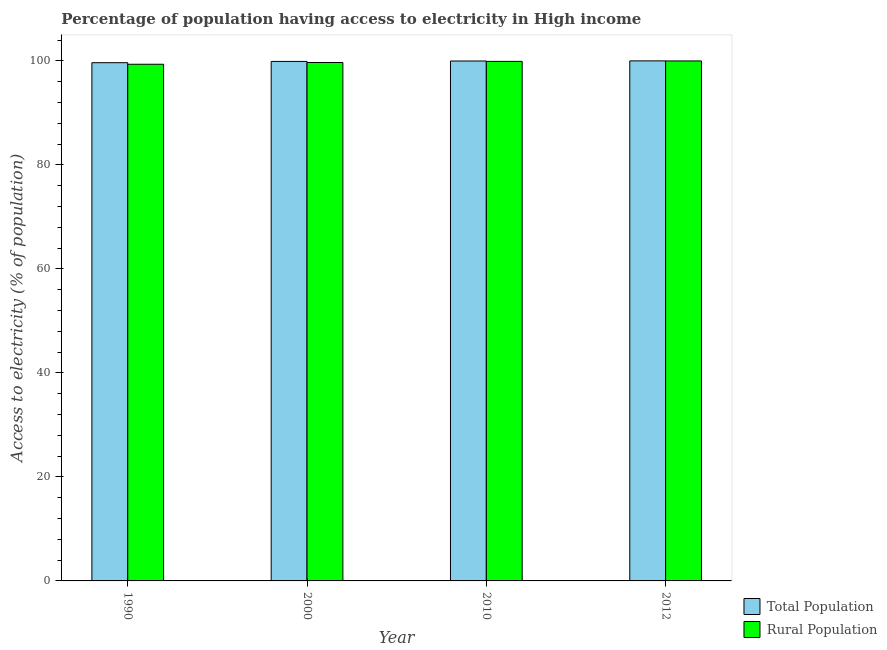How many different coloured bars are there?
Your answer should be compact. 2. How many groups of bars are there?
Your answer should be very brief. 4. Are the number of bars on each tick of the X-axis equal?
Ensure brevity in your answer.  Yes. How many bars are there on the 2nd tick from the left?
Keep it short and to the point. 2. How many bars are there on the 2nd tick from the right?
Keep it short and to the point. 2. What is the label of the 4th group of bars from the left?
Give a very brief answer. 2012. What is the percentage of population having access to electricity in 2010?
Offer a very short reply. 99.97. Across all years, what is the maximum percentage of population having access to electricity?
Provide a short and direct response. 99.99. Across all years, what is the minimum percentage of population having access to electricity?
Offer a very short reply. 99.64. What is the total percentage of rural population having access to electricity in the graph?
Provide a short and direct response. 398.9. What is the difference between the percentage of population having access to electricity in 1990 and that in 2010?
Keep it short and to the point. -0.33. What is the difference between the percentage of rural population having access to electricity in 1990 and the percentage of population having access to electricity in 2010?
Ensure brevity in your answer.  -0.55. What is the average percentage of rural population having access to electricity per year?
Make the answer very short. 99.73. In how many years, is the percentage of population having access to electricity greater than 88 %?
Provide a succinct answer. 4. What is the ratio of the percentage of rural population having access to electricity in 1990 to that in 2000?
Keep it short and to the point. 1. What is the difference between the highest and the second highest percentage of rural population having access to electricity?
Give a very brief answer. 0.08. What is the difference between the highest and the lowest percentage of rural population having access to electricity?
Your answer should be compact. 0.64. Is the sum of the percentage of rural population having access to electricity in 1990 and 2012 greater than the maximum percentage of population having access to electricity across all years?
Provide a short and direct response. Yes. What does the 1st bar from the left in 1990 represents?
Offer a very short reply. Total Population. What does the 2nd bar from the right in 2010 represents?
Offer a very short reply. Total Population. How many bars are there?
Provide a succinct answer. 8. How many years are there in the graph?
Ensure brevity in your answer.  4. Are the values on the major ticks of Y-axis written in scientific E-notation?
Provide a short and direct response. No. Does the graph contain grids?
Your response must be concise. No. Where does the legend appear in the graph?
Your response must be concise. Bottom right. How many legend labels are there?
Provide a short and direct response. 2. What is the title of the graph?
Your response must be concise. Percentage of population having access to electricity in High income. What is the label or title of the Y-axis?
Your response must be concise. Access to electricity (% of population). What is the Access to electricity (% of population) of Total Population in 1990?
Your response must be concise. 99.64. What is the Access to electricity (% of population) in Rural Population in 1990?
Make the answer very short. 99.34. What is the Access to electricity (% of population) in Total Population in 2000?
Provide a short and direct response. 99.89. What is the Access to electricity (% of population) of Rural Population in 2000?
Offer a very short reply. 99.68. What is the Access to electricity (% of population) of Total Population in 2010?
Make the answer very short. 99.97. What is the Access to electricity (% of population) in Rural Population in 2010?
Your answer should be very brief. 99.9. What is the Access to electricity (% of population) of Total Population in 2012?
Your response must be concise. 99.99. What is the Access to electricity (% of population) of Rural Population in 2012?
Ensure brevity in your answer.  99.98. Across all years, what is the maximum Access to electricity (% of population) of Total Population?
Your answer should be very brief. 99.99. Across all years, what is the maximum Access to electricity (% of population) in Rural Population?
Your answer should be compact. 99.98. Across all years, what is the minimum Access to electricity (% of population) of Total Population?
Make the answer very short. 99.64. Across all years, what is the minimum Access to electricity (% of population) in Rural Population?
Offer a terse response. 99.34. What is the total Access to electricity (% of population) in Total Population in the graph?
Your answer should be compact. 399.49. What is the total Access to electricity (% of population) in Rural Population in the graph?
Provide a succinct answer. 398.9. What is the difference between the Access to electricity (% of population) of Total Population in 1990 and that in 2000?
Keep it short and to the point. -0.24. What is the difference between the Access to electricity (% of population) in Rural Population in 1990 and that in 2000?
Your answer should be compact. -0.34. What is the difference between the Access to electricity (% of population) in Total Population in 1990 and that in 2010?
Provide a succinct answer. -0.33. What is the difference between the Access to electricity (% of population) in Rural Population in 1990 and that in 2010?
Ensure brevity in your answer.  -0.55. What is the difference between the Access to electricity (% of population) of Total Population in 1990 and that in 2012?
Make the answer very short. -0.35. What is the difference between the Access to electricity (% of population) in Rural Population in 1990 and that in 2012?
Your response must be concise. -0.64. What is the difference between the Access to electricity (% of population) of Total Population in 2000 and that in 2010?
Your answer should be compact. -0.08. What is the difference between the Access to electricity (% of population) of Rural Population in 2000 and that in 2010?
Your answer should be compact. -0.21. What is the difference between the Access to electricity (% of population) of Total Population in 2000 and that in 2012?
Make the answer very short. -0.11. What is the difference between the Access to electricity (% of population) in Rural Population in 2000 and that in 2012?
Your answer should be very brief. -0.3. What is the difference between the Access to electricity (% of population) of Total Population in 2010 and that in 2012?
Keep it short and to the point. -0.02. What is the difference between the Access to electricity (% of population) in Rural Population in 2010 and that in 2012?
Keep it short and to the point. -0.08. What is the difference between the Access to electricity (% of population) in Total Population in 1990 and the Access to electricity (% of population) in Rural Population in 2000?
Give a very brief answer. -0.04. What is the difference between the Access to electricity (% of population) in Total Population in 1990 and the Access to electricity (% of population) in Rural Population in 2010?
Your answer should be very brief. -0.25. What is the difference between the Access to electricity (% of population) in Total Population in 1990 and the Access to electricity (% of population) in Rural Population in 2012?
Provide a short and direct response. -0.34. What is the difference between the Access to electricity (% of population) in Total Population in 2000 and the Access to electricity (% of population) in Rural Population in 2010?
Keep it short and to the point. -0.01. What is the difference between the Access to electricity (% of population) of Total Population in 2000 and the Access to electricity (% of population) of Rural Population in 2012?
Offer a terse response. -0.09. What is the difference between the Access to electricity (% of population) of Total Population in 2010 and the Access to electricity (% of population) of Rural Population in 2012?
Provide a short and direct response. -0.01. What is the average Access to electricity (% of population) in Total Population per year?
Provide a short and direct response. 99.87. What is the average Access to electricity (% of population) of Rural Population per year?
Give a very brief answer. 99.73. In the year 1990, what is the difference between the Access to electricity (% of population) of Total Population and Access to electricity (% of population) of Rural Population?
Your answer should be compact. 0.3. In the year 2000, what is the difference between the Access to electricity (% of population) of Total Population and Access to electricity (% of population) of Rural Population?
Provide a short and direct response. 0.2. In the year 2010, what is the difference between the Access to electricity (% of population) in Total Population and Access to electricity (% of population) in Rural Population?
Give a very brief answer. 0.07. In the year 2012, what is the difference between the Access to electricity (% of population) in Total Population and Access to electricity (% of population) in Rural Population?
Keep it short and to the point. 0.01. What is the ratio of the Access to electricity (% of population) in Total Population in 1990 to that in 2000?
Provide a short and direct response. 1. What is the ratio of the Access to electricity (% of population) of Total Population in 1990 to that in 2010?
Ensure brevity in your answer.  1. What is the ratio of the Access to electricity (% of population) in Rural Population in 1990 to that in 2010?
Provide a short and direct response. 0.99. What is the ratio of the Access to electricity (% of population) of Total Population in 1990 to that in 2012?
Offer a very short reply. 1. What is the ratio of the Access to electricity (% of population) in Rural Population in 2000 to that in 2010?
Offer a very short reply. 1. What is the ratio of the Access to electricity (% of population) of Total Population in 2010 to that in 2012?
Keep it short and to the point. 1. What is the ratio of the Access to electricity (% of population) in Rural Population in 2010 to that in 2012?
Your answer should be compact. 1. What is the difference between the highest and the second highest Access to electricity (% of population) of Total Population?
Your response must be concise. 0.02. What is the difference between the highest and the second highest Access to electricity (% of population) in Rural Population?
Make the answer very short. 0.08. What is the difference between the highest and the lowest Access to electricity (% of population) in Total Population?
Provide a succinct answer. 0.35. What is the difference between the highest and the lowest Access to electricity (% of population) of Rural Population?
Provide a succinct answer. 0.64. 